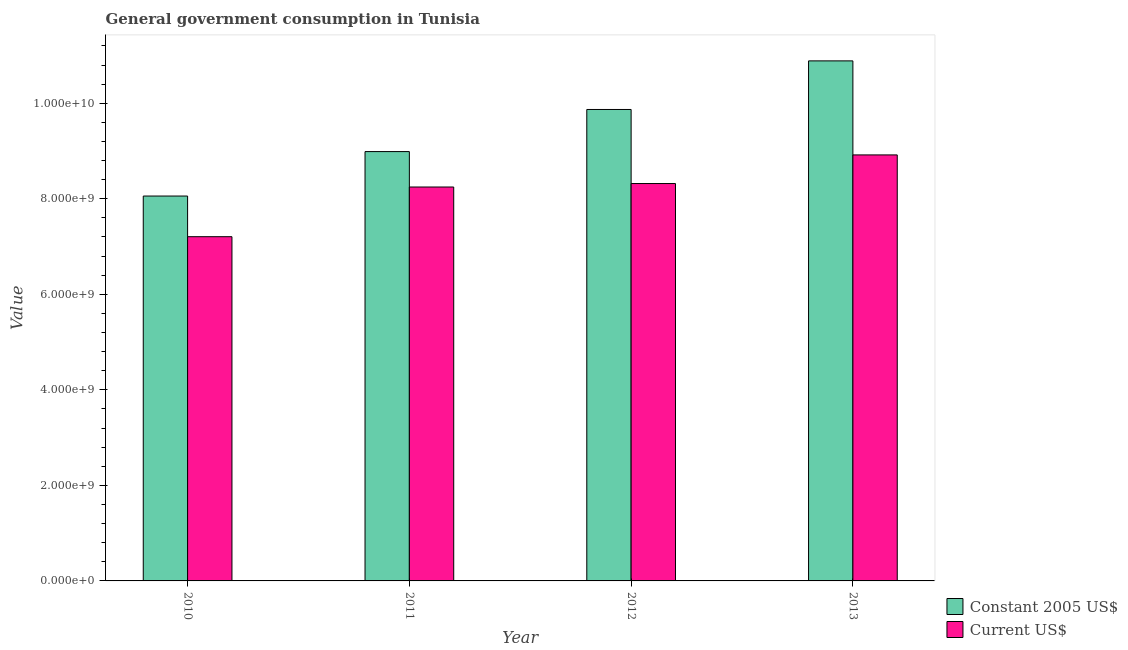How many different coloured bars are there?
Provide a short and direct response. 2. How many groups of bars are there?
Offer a very short reply. 4. Are the number of bars per tick equal to the number of legend labels?
Give a very brief answer. Yes. What is the label of the 1st group of bars from the left?
Offer a very short reply. 2010. What is the value consumed in constant 2005 us$ in 2012?
Your response must be concise. 9.87e+09. Across all years, what is the maximum value consumed in current us$?
Offer a very short reply. 8.92e+09. Across all years, what is the minimum value consumed in constant 2005 us$?
Offer a very short reply. 8.06e+09. In which year was the value consumed in current us$ maximum?
Ensure brevity in your answer.  2013. In which year was the value consumed in constant 2005 us$ minimum?
Your response must be concise. 2010. What is the total value consumed in constant 2005 us$ in the graph?
Provide a succinct answer. 3.78e+1. What is the difference between the value consumed in constant 2005 us$ in 2010 and that in 2011?
Give a very brief answer. -9.31e+08. What is the difference between the value consumed in current us$ in 2011 and the value consumed in constant 2005 us$ in 2010?
Keep it short and to the point. 1.04e+09. What is the average value consumed in constant 2005 us$ per year?
Provide a short and direct response. 9.45e+09. In the year 2013, what is the difference between the value consumed in constant 2005 us$ and value consumed in current us$?
Your response must be concise. 0. In how many years, is the value consumed in constant 2005 us$ greater than 2800000000?
Provide a succinct answer. 4. What is the ratio of the value consumed in current us$ in 2010 to that in 2013?
Your answer should be compact. 0.81. Is the value consumed in current us$ in 2010 less than that in 2013?
Make the answer very short. Yes. Is the difference between the value consumed in current us$ in 2010 and 2013 greater than the difference between the value consumed in constant 2005 us$ in 2010 and 2013?
Keep it short and to the point. No. What is the difference between the highest and the second highest value consumed in current us$?
Your answer should be very brief. 5.99e+08. What is the difference between the highest and the lowest value consumed in constant 2005 us$?
Provide a short and direct response. 2.83e+09. In how many years, is the value consumed in current us$ greater than the average value consumed in current us$ taken over all years?
Make the answer very short. 3. Is the sum of the value consumed in current us$ in 2011 and 2013 greater than the maximum value consumed in constant 2005 us$ across all years?
Your answer should be compact. Yes. What does the 1st bar from the left in 2013 represents?
Offer a terse response. Constant 2005 US$. What does the 1st bar from the right in 2013 represents?
Ensure brevity in your answer.  Current US$. How many bars are there?
Make the answer very short. 8. Are all the bars in the graph horizontal?
Offer a terse response. No. How many years are there in the graph?
Give a very brief answer. 4. What is the difference between two consecutive major ticks on the Y-axis?
Your response must be concise. 2.00e+09. Are the values on the major ticks of Y-axis written in scientific E-notation?
Your response must be concise. Yes. Does the graph contain grids?
Your response must be concise. No. How many legend labels are there?
Provide a short and direct response. 2. How are the legend labels stacked?
Provide a short and direct response. Vertical. What is the title of the graph?
Your response must be concise. General government consumption in Tunisia. Does "Methane" appear as one of the legend labels in the graph?
Make the answer very short. No. What is the label or title of the X-axis?
Your answer should be very brief. Year. What is the label or title of the Y-axis?
Provide a succinct answer. Value. What is the Value of Constant 2005 US$ in 2010?
Ensure brevity in your answer.  8.06e+09. What is the Value in Current US$ in 2010?
Provide a short and direct response. 7.21e+09. What is the Value in Constant 2005 US$ in 2011?
Your answer should be compact. 8.99e+09. What is the Value of Current US$ in 2011?
Your answer should be very brief. 8.25e+09. What is the Value in Constant 2005 US$ in 2012?
Give a very brief answer. 9.87e+09. What is the Value of Current US$ in 2012?
Your answer should be compact. 8.32e+09. What is the Value in Constant 2005 US$ in 2013?
Make the answer very short. 1.09e+1. What is the Value of Current US$ in 2013?
Your answer should be compact. 8.92e+09. Across all years, what is the maximum Value of Constant 2005 US$?
Make the answer very short. 1.09e+1. Across all years, what is the maximum Value of Current US$?
Keep it short and to the point. 8.92e+09. Across all years, what is the minimum Value in Constant 2005 US$?
Provide a short and direct response. 8.06e+09. Across all years, what is the minimum Value of Current US$?
Offer a very short reply. 7.21e+09. What is the total Value of Constant 2005 US$ in the graph?
Give a very brief answer. 3.78e+1. What is the total Value in Current US$ in the graph?
Your answer should be very brief. 3.27e+1. What is the difference between the Value of Constant 2005 US$ in 2010 and that in 2011?
Your answer should be very brief. -9.31e+08. What is the difference between the Value of Current US$ in 2010 and that in 2011?
Make the answer very short. -1.04e+09. What is the difference between the Value in Constant 2005 US$ in 2010 and that in 2012?
Your response must be concise. -1.81e+09. What is the difference between the Value of Current US$ in 2010 and that in 2012?
Provide a short and direct response. -1.11e+09. What is the difference between the Value in Constant 2005 US$ in 2010 and that in 2013?
Your answer should be very brief. -2.83e+09. What is the difference between the Value in Current US$ in 2010 and that in 2013?
Provide a succinct answer. -1.71e+09. What is the difference between the Value in Constant 2005 US$ in 2011 and that in 2012?
Provide a succinct answer. -8.81e+08. What is the difference between the Value of Current US$ in 2011 and that in 2012?
Your answer should be compact. -7.29e+07. What is the difference between the Value of Constant 2005 US$ in 2011 and that in 2013?
Your answer should be compact. -1.90e+09. What is the difference between the Value of Current US$ in 2011 and that in 2013?
Your response must be concise. -6.72e+08. What is the difference between the Value in Constant 2005 US$ in 2012 and that in 2013?
Provide a succinct answer. -1.02e+09. What is the difference between the Value of Current US$ in 2012 and that in 2013?
Your response must be concise. -5.99e+08. What is the difference between the Value in Constant 2005 US$ in 2010 and the Value in Current US$ in 2011?
Provide a succinct answer. -1.89e+08. What is the difference between the Value in Constant 2005 US$ in 2010 and the Value in Current US$ in 2012?
Give a very brief answer. -2.62e+08. What is the difference between the Value of Constant 2005 US$ in 2010 and the Value of Current US$ in 2013?
Provide a succinct answer. -8.61e+08. What is the difference between the Value of Constant 2005 US$ in 2011 and the Value of Current US$ in 2012?
Keep it short and to the point. 6.69e+08. What is the difference between the Value in Constant 2005 US$ in 2011 and the Value in Current US$ in 2013?
Offer a very short reply. 6.98e+07. What is the difference between the Value in Constant 2005 US$ in 2012 and the Value in Current US$ in 2013?
Your response must be concise. 9.51e+08. What is the average Value in Constant 2005 US$ per year?
Make the answer very short. 9.45e+09. What is the average Value in Current US$ per year?
Your answer should be compact. 8.17e+09. In the year 2010, what is the difference between the Value of Constant 2005 US$ and Value of Current US$?
Your answer should be compact. 8.51e+08. In the year 2011, what is the difference between the Value in Constant 2005 US$ and Value in Current US$?
Make the answer very short. 7.42e+08. In the year 2012, what is the difference between the Value in Constant 2005 US$ and Value in Current US$?
Offer a very short reply. 1.55e+09. In the year 2013, what is the difference between the Value in Constant 2005 US$ and Value in Current US$?
Your answer should be very brief. 1.97e+09. What is the ratio of the Value of Constant 2005 US$ in 2010 to that in 2011?
Ensure brevity in your answer.  0.9. What is the ratio of the Value in Current US$ in 2010 to that in 2011?
Keep it short and to the point. 0.87. What is the ratio of the Value in Constant 2005 US$ in 2010 to that in 2012?
Give a very brief answer. 0.82. What is the ratio of the Value of Current US$ in 2010 to that in 2012?
Your answer should be very brief. 0.87. What is the ratio of the Value in Constant 2005 US$ in 2010 to that in 2013?
Your response must be concise. 0.74. What is the ratio of the Value in Current US$ in 2010 to that in 2013?
Offer a very short reply. 0.81. What is the ratio of the Value of Constant 2005 US$ in 2011 to that in 2012?
Provide a short and direct response. 0.91. What is the ratio of the Value in Current US$ in 2011 to that in 2012?
Provide a short and direct response. 0.99. What is the ratio of the Value in Constant 2005 US$ in 2011 to that in 2013?
Provide a succinct answer. 0.83. What is the ratio of the Value of Current US$ in 2011 to that in 2013?
Provide a succinct answer. 0.92. What is the ratio of the Value of Constant 2005 US$ in 2012 to that in 2013?
Your response must be concise. 0.91. What is the ratio of the Value of Current US$ in 2012 to that in 2013?
Your answer should be compact. 0.93. What is the difference between the highest and the second highest Value of Constant 2005 US$?
Give a very brief answer. 1.02e+09. What is the difference between the highest and the second highest Value of Current US$?
Provide a short and direct response. 5.99e+08. What is the difference between the highest and the lowest Value of Constant 2005 US$?
Make the answer very short. 2.83e+09. What is the difference between the highest and the lowest Value in Current US$?
Your answer should be very brief. 1.71e+09. 